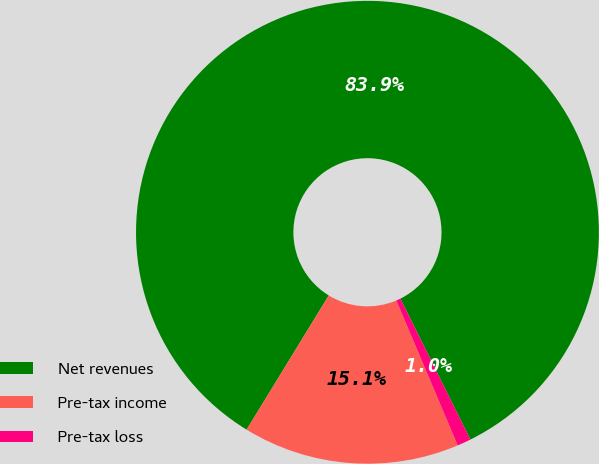Convert chart. <chart><loc_0><loc_0><loc_500><loc_500><pie_chart><fcel>Net revenues<fcel>Pre-tax income<fcel>Pre-tax loss<nl><fcel>83.92%<fcel>15.12%<fcel>0.96%<nl></chart> 